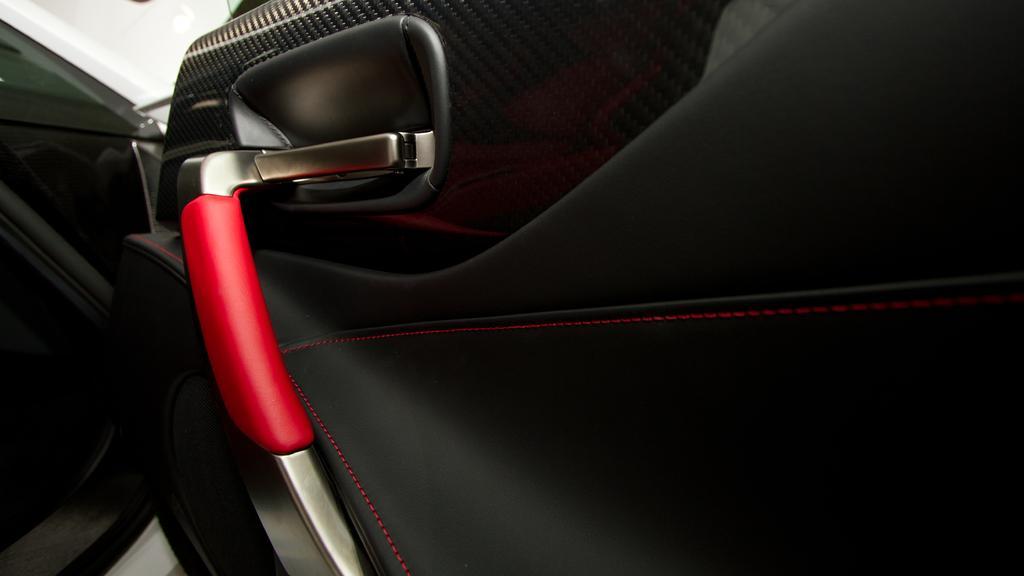Can you describe this image briefly? In this picture we can observe a car door which is in black color. We can observe a red color handle. On the left side there is a white color car. 